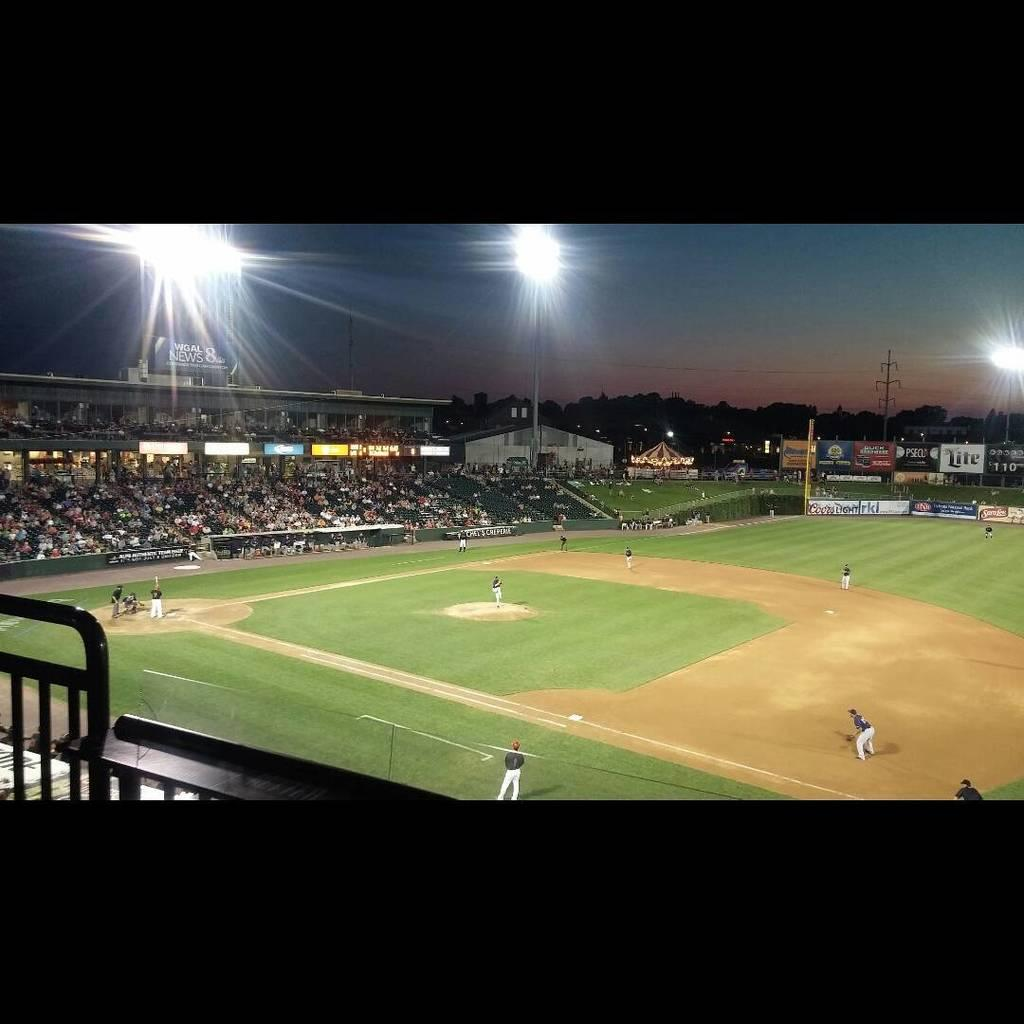What type of venue is depicted in the image? There is a stadium in the image. What activity is taking place in the stadium? There are players on the ground in the stadium. Who is present to watch the activity in the stadium? There are spectators around the ground. What can be seen behind the spectators in the image? There are lights visible behind the spectators. What type of grape is being used to whip the players on the ground in the image? There is no grape or whipping activity present in the image. 